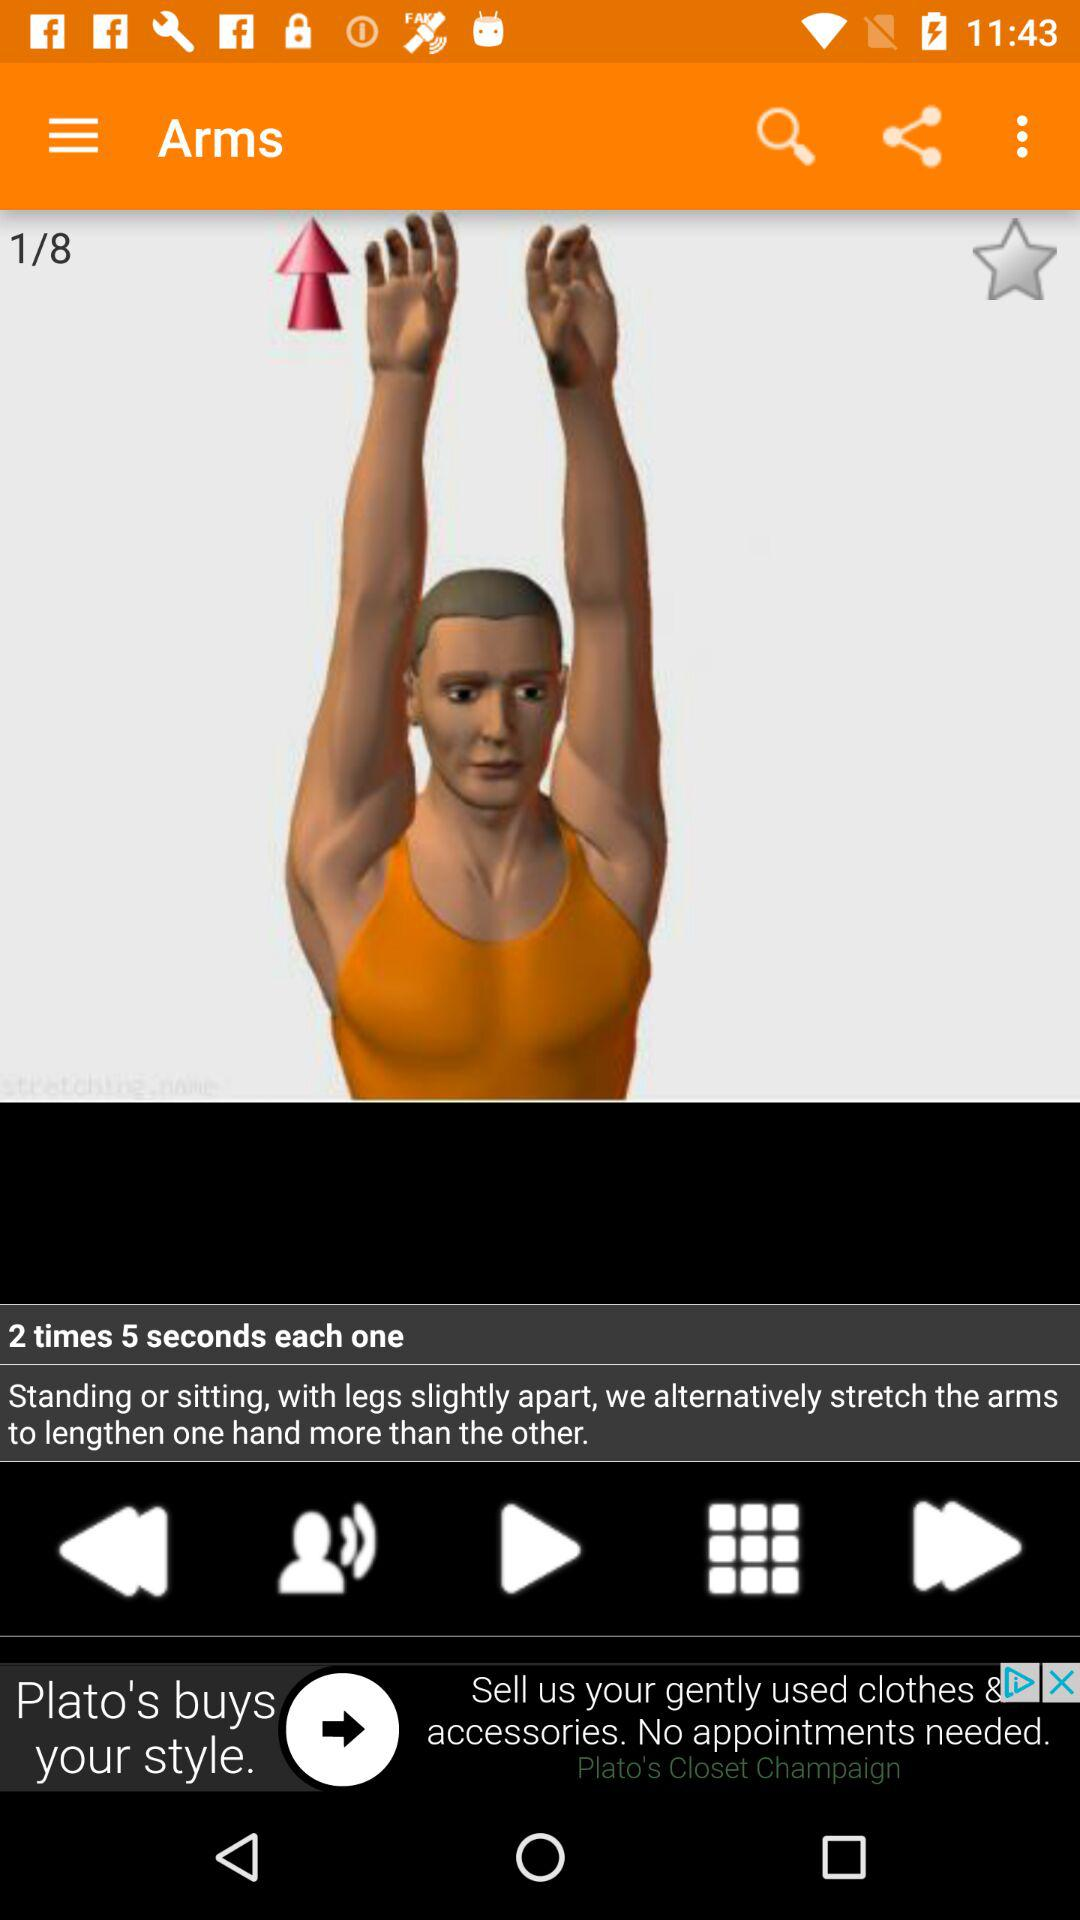What is the number of the current exercise? The number of the current exercise is 1. 